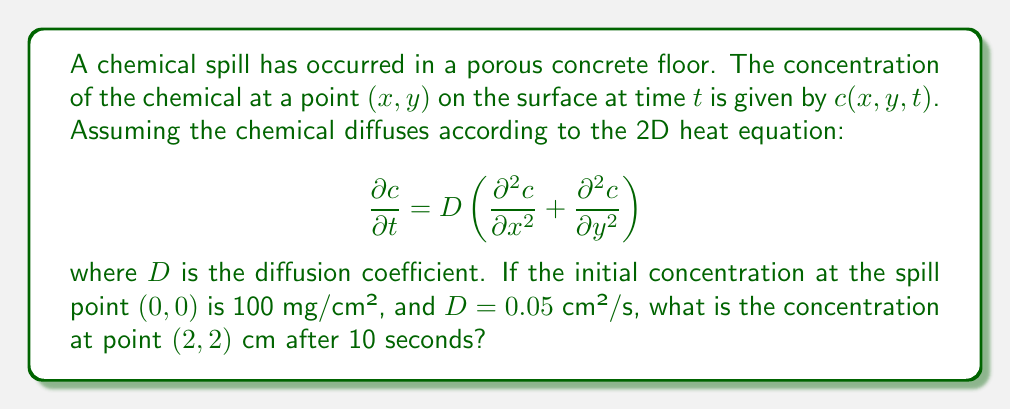What is the answer to this math problem? To solve this problem, we'll use the fundamental solution of the 2D heat equation:

$$c(x,y,t) = \frac{M}{4\pi Dt} e^{-\frac{x^2+y^2}{4Dt}}$$

where $M$ is the total mass of the chemical.

Step 1: Calculate the total mass $M$.
Since the initial concentration is given as 100 mg/cm² at a point, we can assume this is a point source. The total mass is then simply 100 mg.

Step 2: Substitute the given values into the equation.
$x = y = 2$ cm
$t = 10$ s
$D = 0.05$ cm²/s
$M = 100$ mg

$$c(2,2,10) = \frac{100}{4\pi(0.05)(10)} e^{-\frac{2^2+2^2}{4(0.05)(10)}}$$

Step 3: Simplify the expression.
$$c(2,2,10) = \frac{100}{2\pi} e^{-\frac{8}{2}}$$

Step 4: Calculate the final result.
$$c(2,2,10) \approx 0.7391 \text{ mg/cm²}$$
Answer: 0.7391 mg/cm² 